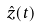Convert formula to latex. <formula><loc_0><loc_0><loc_500><loc_500>\hat { z } ( t )</formula> 